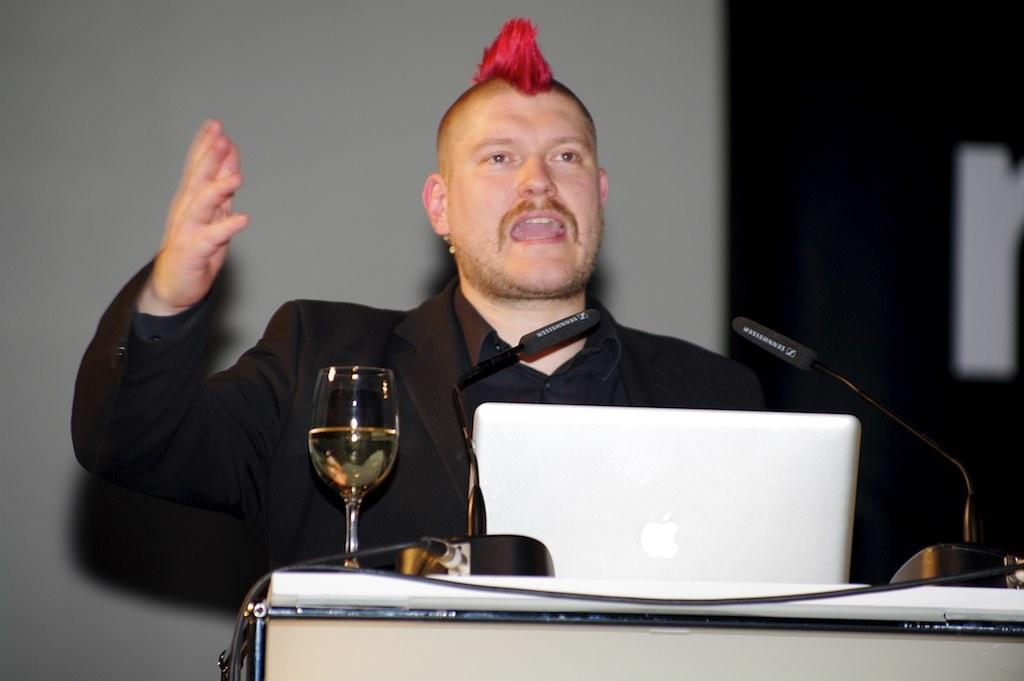Who is the main subject in the image? There is a man in the center of the image. What is in front of the man? There is a desk in front of the man. What electronic device is on the desk? There is a laptop on the desk. What other objects are on the desk? There is a glass and two microphones on the desk. What type of art is the owl creating on the desk? There is no owl or art present in the image. Can you tell me what the uncle is doing with the microphones? There is no uncle mentioned in the image, and therefore no actions involving microphones can be observed. 